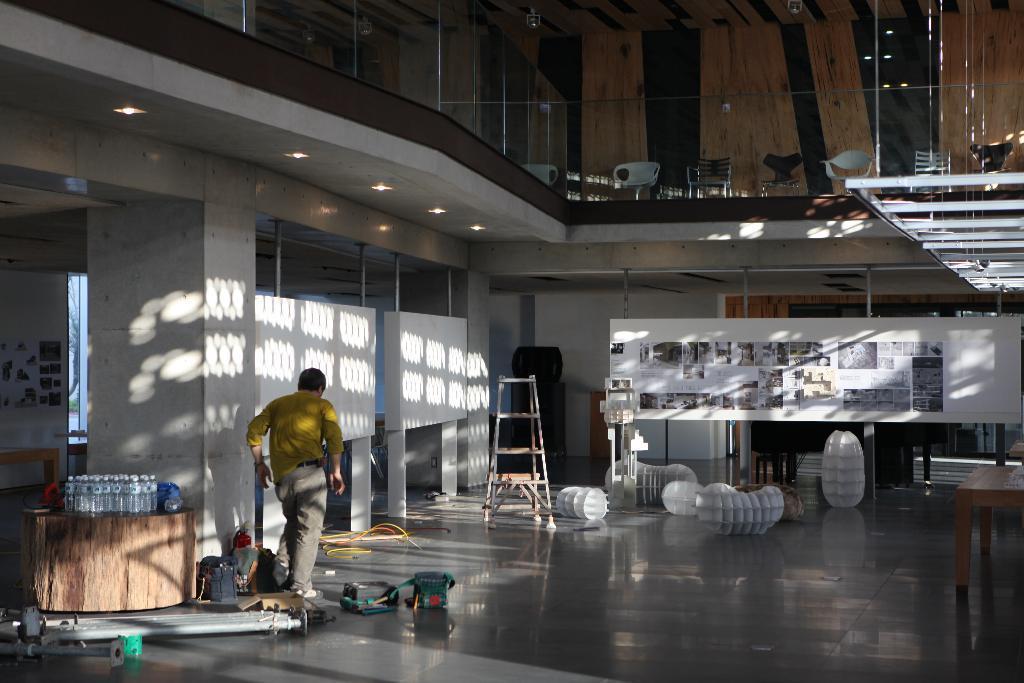How would you summarize this image in a sentence or two? This image is taken in the building. In this image we can see a person. We can also see the bottles, tables, step ladder stool and also some other objects on the floor. Image also consists of boards with papers and in the papers we can see the images and also text. At the top we can see the chairs, wooden walls and also glass fence. Ceiling lights are also visible in this image. 